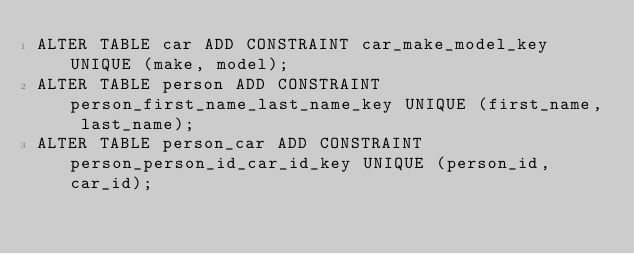<code> <loc_0><loc_0><loc_500><loc_500><_SQL_>ALTER TABLE car ADD CONSTRAINT car_make_model_key UNIQUE (make, model);
ALTER TABLE person ADD CONSTRAINT person_first_name_last_name_key UNIQUE (first_name, last_name);
ALTER TABLE person_car ADD CONSTRAINT person_person_id_car_id_key UNIQUE (person_id, car_id);
</code> 